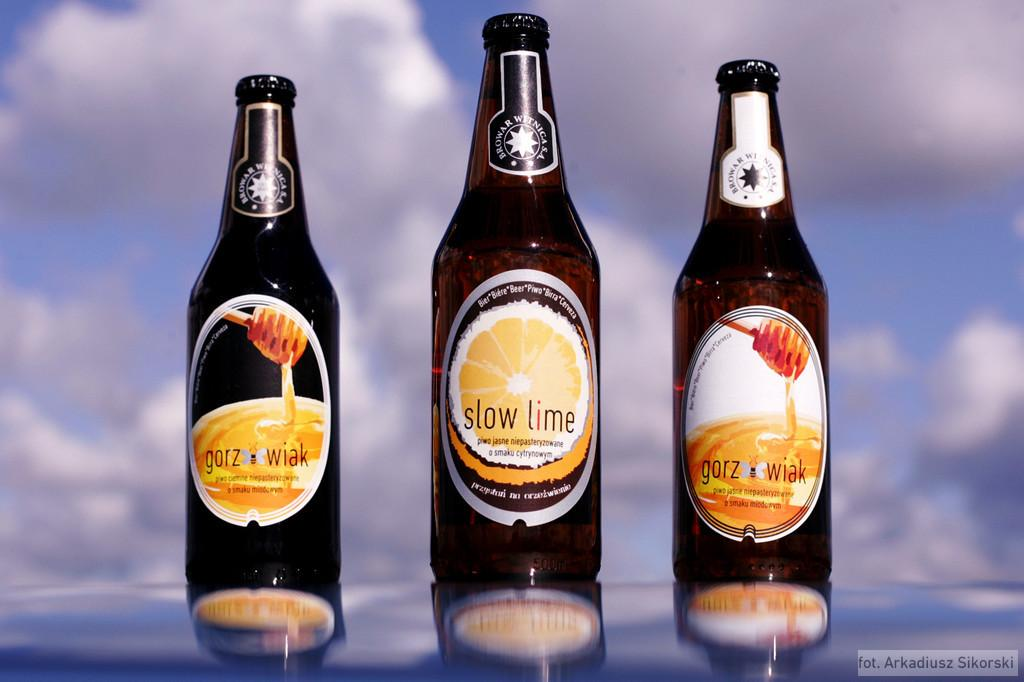<image>
Relay a brief, clear account of the picture shown. The bottle of slow lime beer sits in between the two bottles of honeyed beer. 